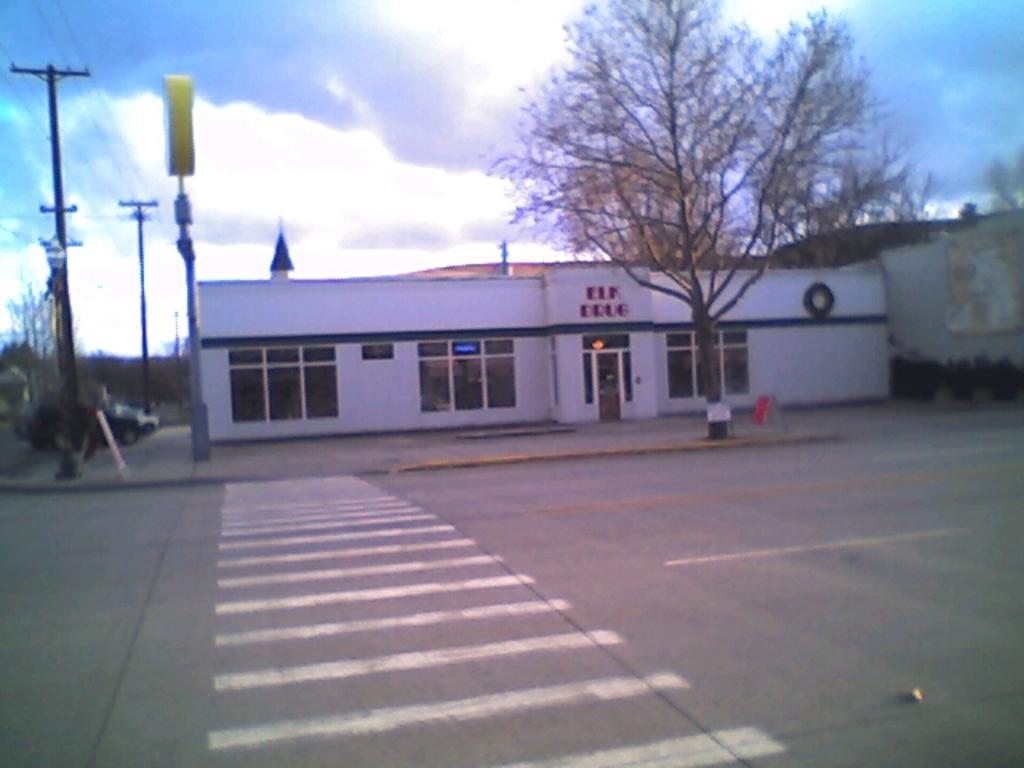What can be seen in the sky in the image? The sky with clouds is visible in the image. What structures are related to electricity in the image? There are electric poles and electric cables present in the image. What types of transportation are visible in the image? Motor vehicles are visible in the image. What kind of signage is present in the image? There is an information board in the image. What type of pathway is shown in the image? A road is present in the image. What type of buildings can be seen in the image? Buildings are visible in the image. What type of plant life is present in the image? A tree is present in the image. Can you tell me how many veins are visible on the tree in the image? There are no veins visible on the tree in the image, as veins are a part of living organisms and not visible on the surface of a tree. 